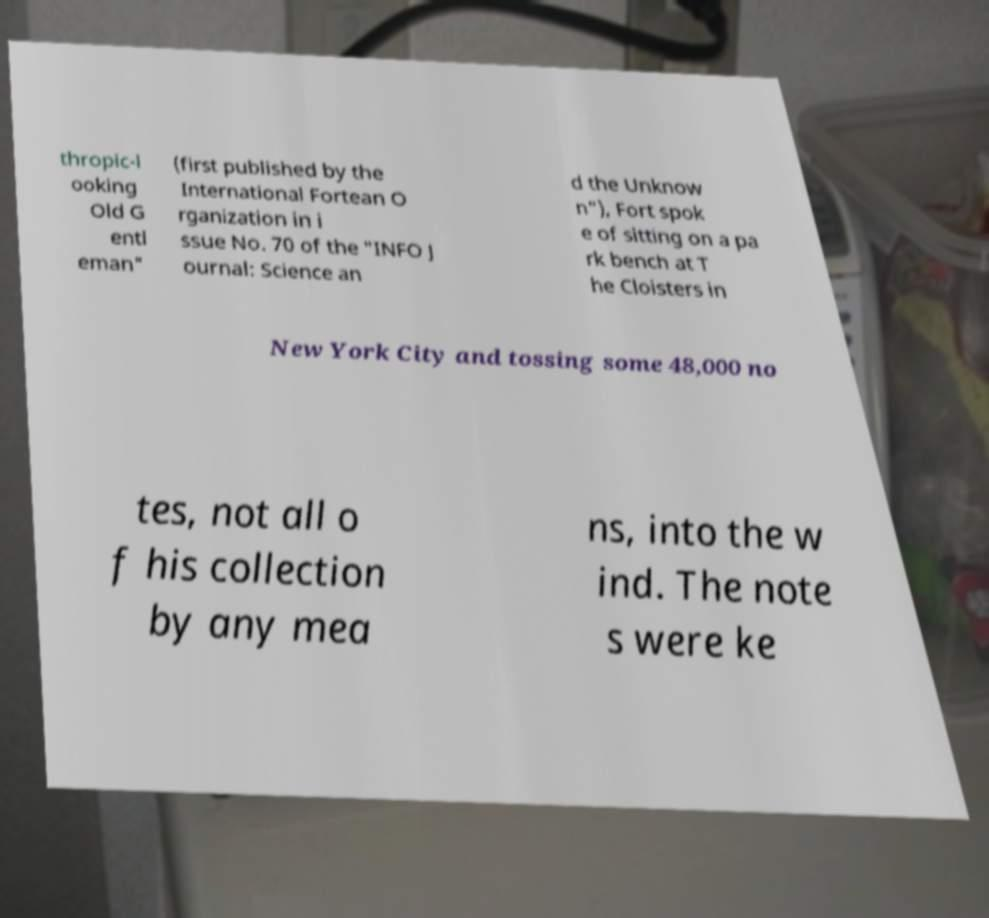Could you assist in decoding the text presented in this image and type it out clearly? thropic-l ooking Old G entl eman" (first published by the International Fortean O rganization in i ssue No. 70 of the "INFO J ournal: Science an d the Unknow n"), Fort spok e of sitting on a pa rk bench at T he Cloisters in New York City and tossing some 48,000 no tes, not all o f his collection by any mea ns, into the w ind. The note s were ke 